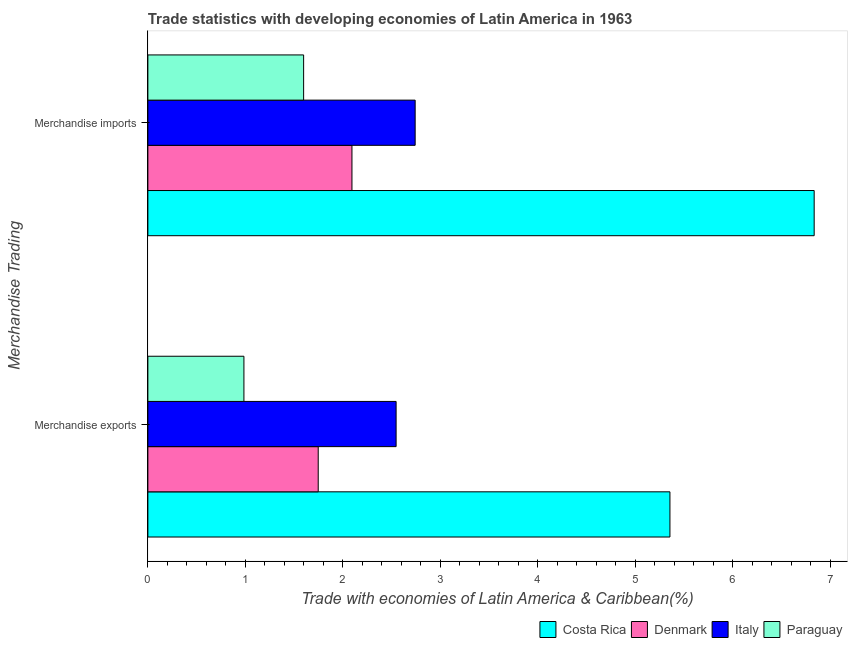How many different coloured bars are there?
Make the answer very short. 4. Are the number of bars per tick equal to the number of legend labels?
Your answer should be very brief. Yes. How many bars are there on the 1st tick from the bottom?
Keep it short and to the point. 4. What is the label of the 1st group of bars from the top?
Give a very brief answer. Merchandise imports. What is the merchandise exports in Italy?
Keep it short and to the point. 2.55. Across all countries, what is the maximum merchandise exports?
Your answer should be very brief. 5.36. Across all countries, what is the minimum merchandise imports?
Provide a succinct answer. 1.6. In which country was the merchandise exports minimum?
Your response must be concise. Paraguay. What is the total merchandise imports in the graph?
Keep it short and to the point. 13.27. What is the difference between the merchandise exports in Italy and that in Costa Rica?
Provide a succinct answer. -2.81. What is the difference between the merchandise exports in Costa Rica and the merchandise imports in Paraguay?
Offer a terse response. 3.76. What is the average merchandise exports per country?
Ensure brevity in your answer.  2.66. What is the difference between the merchandise imports and merchandise exports in Italy?
Make the answer very short. 0.2. What is the ratio of the merchandise exports in Italy to that in Denmark?
Your answer should be very brief. 1.46. In how many countries, is the merchandise exports greater than the average merchandise exports taken over all countries?
Offer a very short reply. 1. What does the 3rd bar from the top in Merchandise exports represents?
Provide a succinct answer. Denmark. What does the 2nd bar from the bottom in Merchandise imports represents?
Give a very brief answer. Denmark. How many bars are there?
Ensure brevity in your answer.  8. How many countries are there in the graph?
Keep it short and to the point. 4. Are the values on the major ticks of X-axis written in scientific E-notation?
Provide a succinct answer. No. Does the graph contain any zero values?
Offer a very short reply. No. Does the graph contain grids?
Offer a very short reply. No. Where does the legend appear in the graph?
Provide a succinct answer. Bottom right. How many legend labels are there?
Your answer should be compact. 4. What is the title of the graph?
Offer a terse response. Trade statistics with developing economies of Latin America in 1963. Does "Monaco" appear as one of the legend labels in the graph?
Make the answer very short. No. What is the label or title of the X-axis?
Offer a terse response. Trade with economies of Latin America & Caribbean(%). What is the label or title of the Y-axis?
Offer a very short reply. Merchandise Trading. What is the Trade with economies of Latin America & Caribbean(%) in Costa Rica in Merchandise exports?
Your answer should be very brief. 5.36. What is the Trade with economies of Latin America & Caribbean(%) of Denmark in Merchandise exports?
Provide a succinct answer. 1.75. What is the Trade with economies of Latin America & Caribbean(%) in Italy in Merchandise exports?
Provide a short and direct response. 2.55. What is the Trade with economies of Latin America & Caribbean(%) of Paraguay in Merchandise exports?
Provide a short and direct response. 0.99. What is the Trade with economies of Latin America & Caribbean(%) in Costa Rica in Merchandise imports?
Ensure brevity in your answer.  6.83. What is the Trade with economies of Latin America & Caribbean(%) of Denmark in Merchandise imports?
Keep it short and to the point. 2.09. What is the Trade with economies of Latin America & Caribbean(%) of Italy in Merchandise imports?
Keep it short and to the point. 2.74. What is the Trade with economies of Latin America & Caribbean(%) in Paraguay in Merchandise imports?
Ensure brevity in your answer.  1.6. Across all Merchandise Trading, what is the maximum Trade with economies of Latin America & Caribbean(%) of Costa Rica?
Your answer should be compact. 6.83. Across all Merchandise Trading, what is the maximum Trade with economies of Latin America & Caribbean(%) of Denmark?
Offer a terse response. 2.09. Across all Merchandise Trading, what is the maximum Trade with economies of Latin America & Caribbean(%) in Italy?
Your answer should be compact. 2.74. Across all Merchandise Trading, what is the maximum Trade with economies of Latin America & Caribbean(%) in Paraguay?
Your answer should be compact. 1.6. Across all Merchandise Trading, what is the minimum Trade with economies of Latin America & Caribbean(%) in Costa Rica?
Your response must be concise. 5.36. Across all Merchandise Trading, what is the minimum Trade with economies of Latin America & Caribbean(%) of Denmark?
Your answer should be compact. 1.75. Across all Merchandise Trading, what is the minimum Trade with economies of Latin America & Caribbean(%) in Italy?
Provide a short and direct response. 2.55. Across all Merchandise Trading, what is the minimum Trade with economies of Latin America & Caribbean(%) of Paraguay?
Ensure brevity in your answer.  0.99. What is the total Trade with economies of Latin America & Caribbean(%) of Costa Rica in the graph?
Make the answer very short. 12.19. What is the total Trade with economies of Latin America & Caribbean(%) of Denmark in the graph?
Your response must be concise. 3.84. What is the total Trade with economies of Latin America & Caribbean(%) of Italy in the graph?
Make the answer very short. 5.29. What is the total Trade with economies of Latin America & Caribbean(%) in Paraguay in the graph?
Keep it short and to the point. 2.58. What is the difference between the Trade with economies of Latin America & Caribbean(%) of Costa Rica in Merchandise exports and that in Merchandise imports?
Keep it short and to the point. -1.48. What is the difference between the Trade with economies of Latin America & Caribbean(%) of Denmark in Merchandise exports and that in Merchandise imports?
Make the answer very short. -0.35. What is the difference between the Trade with economies of Latin America & Caribbean(%) in Italy in Merchandise exports and that in Merchandise imports?
Give a very brief answer. -0.2. What is the difference between the Trade with economies of Latin America & Caribbean(%) of Paraguay in Merchandise exports and that in Merchandise imports?
Provide a succinct answer. -0.61. What is the difference between the Trade with economies of Latin America & Caribbean(%) of Costa Rica in Merchandise exports and the Trade with economies of Latin America & Caribbean(%) of Denmark in Merchandise imports?
Offer a terse response. 3.26. What is the difference between the Trade with economies of Latin America & Caribbean(%) in Costa Rica in Merchandise exports and the Trade with economies of Latin America & Caribbean(%) in Italy in Merchandise imports?
Provide a short and direct response. 2.61. What is the difference between the Trade with economies of Latin America & Caribbean(%) in Costa Rica in Merchandise exports and the Trade with economies of Latin America & Caribbean(%) in Paraguay in Merchandise imports?
Make the answer very short. 3.76. What is the difference between the Trade with economies of Latin America & Caribbean(%) in Denmark in Merchandise exports and the Trade with economies of Latin America & Caribbean(%) in Italy in Merchandise imports?
Offer a terse response. -0.99. What is the difference between the Trade with economies of Latin America & Caribbean(%) in Denmark in Merchandise exports and the Trade with economies of Latin America & Caribbean(%) in Paraguay in Merchandise imports?
Provide a short and direct response. 0.15. What is the difference between the Trade with economies of Latin America & Caribbean(%) in Italy in Merchandise exports and the Trade with economies of Latin America & Caribbean(%) in Paraguay in Merchandise imports?
Your answer should be very brief. 0.95. What is the average Trade with economies of Latin America & Caribbean(%) in Costa Rica per Merchandise Trading?
Provide a succinct answer. 6.09. What is the average Trade with economies of Latin America & Caribbean(%) in Denmark per Merchandise Trading?
Your response must be concise. 1.92. What is the average Trade with economies of Latin America & Caribbean(%) in Italy per Merchandise Trading?
Ensure brevity in your answer.  2.64. What is the average Trade with economies of Latin America & Caribbean(%) in Paraguay per Merchandise Trading?
Provide a short and direct response. 1.29. What is the difference between the Trade with economies of Latin America & Caribbean(%) of Costa Rica and Trade with economies of Latin America & Caribbean(%) of Denmark in Merchandise exports?
Your answer should be very brief. 3.61. What is the difference between the Trade with economies of Latin America & Caribbean(%) in Costa Rica and Trade with economies of Latin America & Caribbean(%) in Italy in Merchandise exports?
Make the answer very short. 2.81. What is the difference between the Trade with economies of Latin America & Caribbean(%) of Costa Rica and Trade with economies of Latin America & Caribbean(%) of Paraguay in Merchandise exports?
Provide a short and direct response. 4.37. What is the difference between the Trade with economies of Latin America & Caribbean(%) of Denmark and Trade with economies of Latin America & Caribbean(%) of Italy in Merchandise exports?
Provide a short and direct response. -0.8. What is the difference between the Trade with economies of Latin America & Caribbean(%) of Denmark and Trade with economies of Latin America & Caribbean(%) of Paraguay in Merchandise exports?
Your answer should be compact. 0.76. What is the difference between the Trade with economies of Latin America & Caribbean(%) of Italy and Trade with economies of Latin America & Caribbean(%) of Paraguay in Merchandise exports?
Ensure brevity in your answer.  1.56. What is the difference between the Trade with economies of Latin America & Caribbean(%) of Costa Rica and Trade with economies of Latin America & Caribbean(%) of Denmark in Merchandise imports?
Offer a very short reply. 4.74. What is the difference between the Trade with economies of Latin America & Caribbean(%) in Costa Rica and Trade with economies of Latin America & Caribbean(%) in Italy in Merchandise imports?
Provide a succinct answer. 4.09. What is the difference between the Trade with economies of Latin America & Caribbean(%) in Costa Rica and Trade with economies of Latin America & Caribbean(%) in Paraguay in Merchandise imports?
Provide a short and direct response. 5.24. What is the difference between the Trade with economies of Latin America & Caribbean(%) of Denmark and Trade with economies of Latin America & Caribbean(%) of Italy in Merchandise imports?
Provide a short and direct response. -0.65. What is the difference between the Trade with economies of Latin America & Caribbean(%) in Denmark and Trade with economies of Latin America & Caribbean(%) in Paraguay in Merchandise imports?
Your response must be concise. 0.5. What is the difference between the Trade with economies of Latin America & Caribbean(%) of Italy and Trade with economies of Latin America & Caribbean(%) of Paraguay in Merchandise imports?
Your response must be concise. 1.14. What is the ratio of the Trade with economies of Latin America & Caribbean(%) of Costa Rica in Merchandise exports to that in Merchandise imports?
Your response must be concise. 0.78. What is the ratio of the Trade with economies of Latin America & Caribbean(%) in Denmark in Merchandise exports to that in Merchandise imports?
Keep it short and to the point. 0.83. What is the ratio of the Trade with economies of Latin America & Caribbean(%) in Italy in Merchandise exports to that in Merchandise imports?
Provide a succinct answer. 0.93. What is the ratio of the Trade with economies of Latin America & Caribbean(%) in Paraguay in Merchandise exports to that in Merchandise imports?
Your response must be concise. 0.62. What is the difference between the highest and the second highest Trade with economies of Latin America & Caribbean(%) of Costa Rica?
Your response must be concise. 1.48. What is the difference between the highest and the second highest Trade with economies of Latin America & Caribbean(%) of Denmark?
Offer a very short reply. 0.35. What is the difference between the highest and the second highest Trade with economies of Latin America & Caribbean(%) of Italy?
Your answer should be very brief. 0.2. What is the difference between the highest and the second highest Trade with economies of Latin America & Caribbean(%) of Paraguay?
Your response must be concise. 0.61. What is the difference between the highest and the lowest Trade with economies of Latin America & Caribbean(%) of Costa Rica?
Provide a short and direct response. 1.48. What is the difference between the highest and the lowest Trade with economies of Latin America & Caribbean(%) in Denmark?
Provide a short and direct response. 0.35. What is the difference between the highest and the lowest Trade with economies of Latin America & Caribbean(%) in Italy?
Provide a succinct answer. 0.2. What is the difference between the highest and the lowest Trade with economies of Latin America & Caribbean(%) in Paraguay?
Offer a terse response. 0.61. 